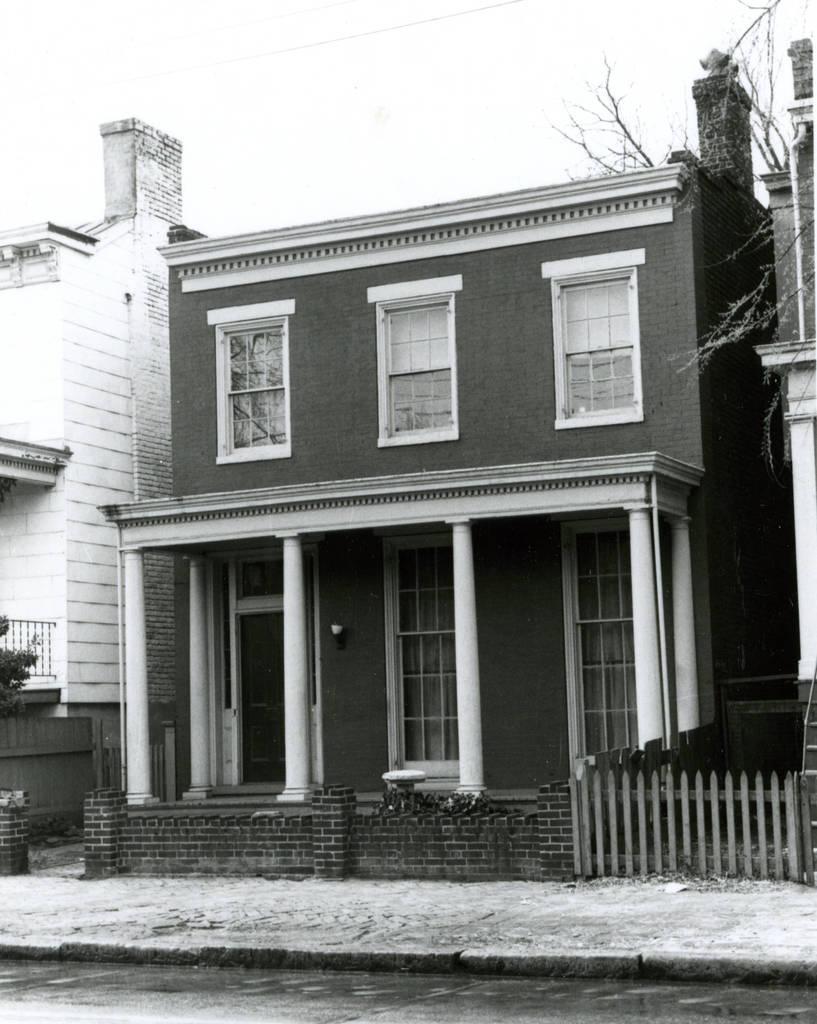Could you give a brief overview of what you see in this image? It is a black and white image, there are buildings. At the top it is the sky. 